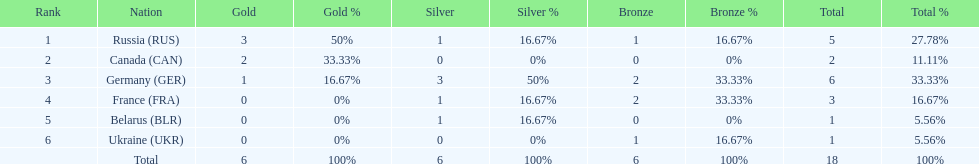Name the country that had the same number of bronze medals as russia. Ukraine. 